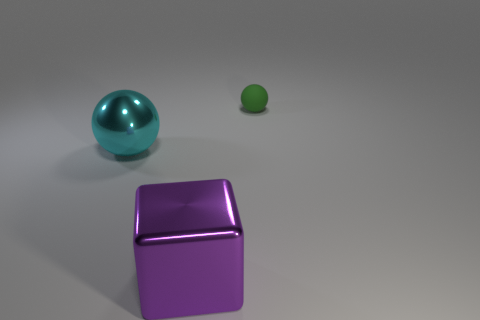Is there anything else that is the same size as the green matte sphere?
Make the answer very short. No. What shape is the thing that is both behind the big purple block and right of the large ball?
Your response must be concise. Sphere. Are there any other metallic things of the same shape as the big purple object?
Give a very brief answer. No. Does the sphere that is in front of the small green matte object have the same size as the sphere that is on the right side of the large shiny ball?
Your answer should be compact. No. Are there more small purple matte cylinders than large metallic balls?
Your response must be concise. No. How many cyan spheres are made of the same material as the big purple object?
Offer a terse response. 1. Is the shape of the purple metal thing the same as the small green matte object?
Make the answer very short. No. There is a shiny cube that is right of the ball in front of the small green object to the right of the big purple object; what size is it?
Offer a very short reply. Large. There is a large metallic thing that is on the right side of the cyan metallic sphere; is there a green rubber object that is to the left of it?
Offer a terse response. No. How many shiny objects are in front of the object to the left of the metallic object in front of the cyan sphere?
Your answer should be very brief. 1. 